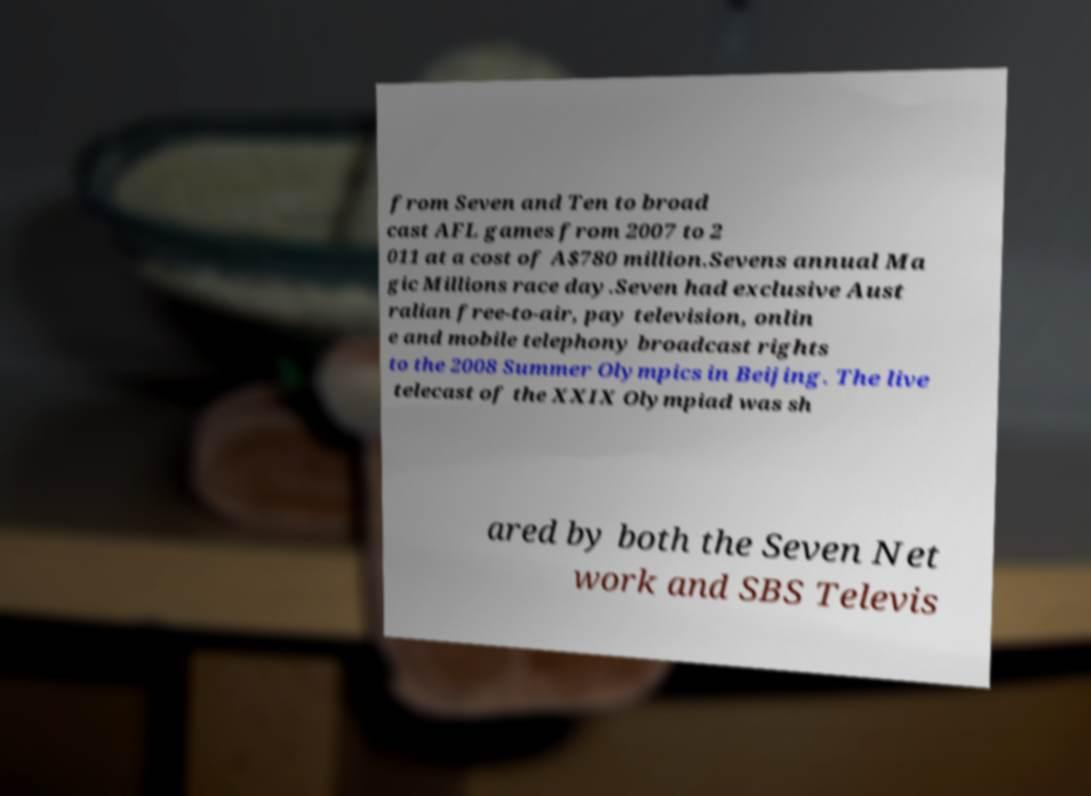What messages or text are displayed in this image? I need them in a readable, typed format. from Seven and Ten to broad cast AFL games from 2007 to 2 011 at a cost of A$780 million.Sevens annual Ma gic Millions race day.Seven had exclusive Aust ralian free-to-air, pay television, onlin e and mobile telephony broadcast rights to the 2008 Summer Olympics in Beijing. The live telecast of the XXIX Olympiad was sh ared by both the Seven Net work and SBS Televis 